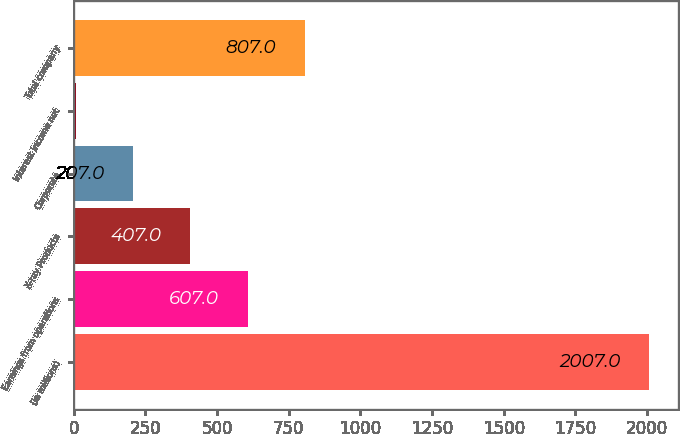Convert chart to OTSL. <chart><loc_0><loc_0><loc_500><loc_500><bar_chart><fcel>(In millions)<fcel>Earnings from operations<fcel>X-ray Products<fcel>Corporate<fcel>Interest income net<fcel>Total company<nl><fcel>2007<fcel>607<fcel>407<fcel>207<fcel>7<fcel>807<nl></chart> 